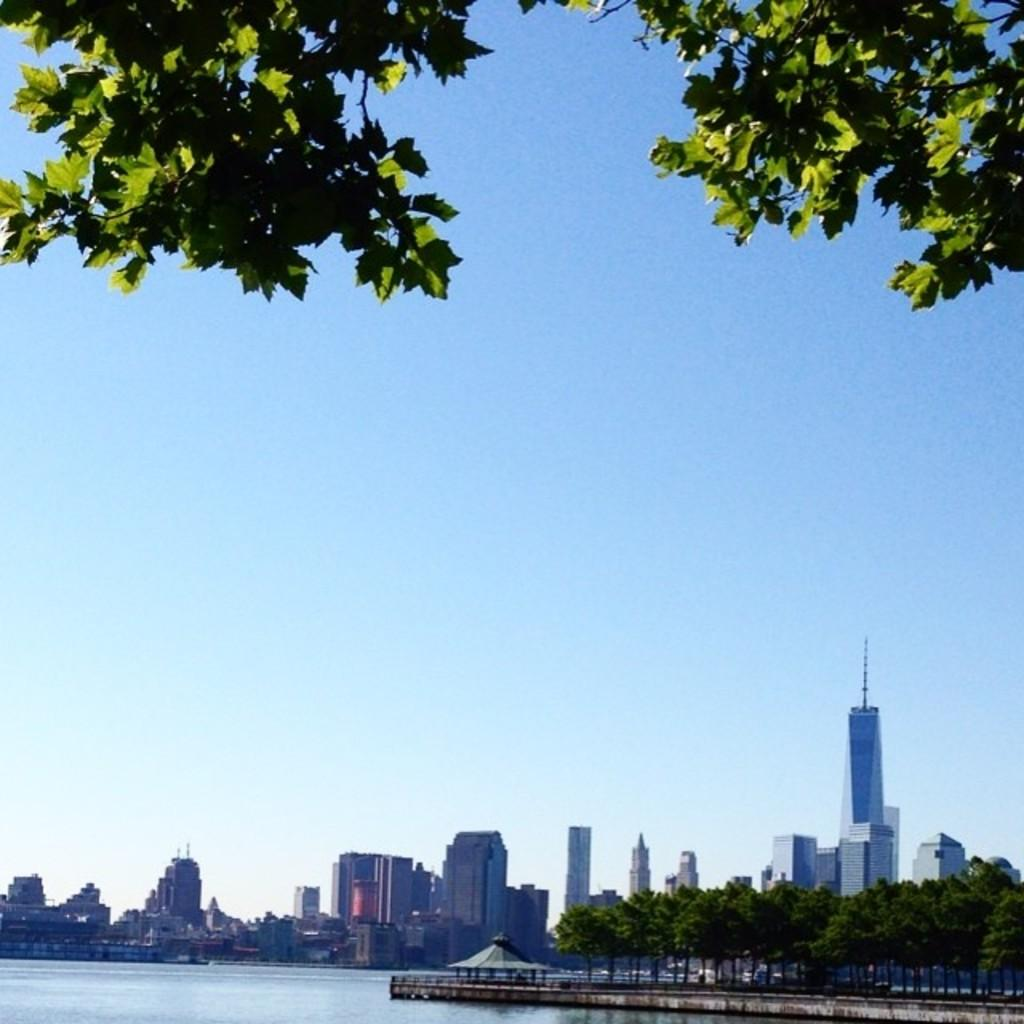What type of structures can be seen in the image? There are buildings in the image. What natural elements are present in the image? There are trees and water at the bottom of the image. What can be seen in the background of the image? The sky is visible in the background of the image. What type of bridge is present in the image? There is a board bridge on the right side of the image. What date is marked on the calendar in the image? There is no calendar present in the image. How does the sailboat navigate through the water in the image? There is no sailboat present in the image; it only features buildings, trees, water, sky, and a board bridge. 